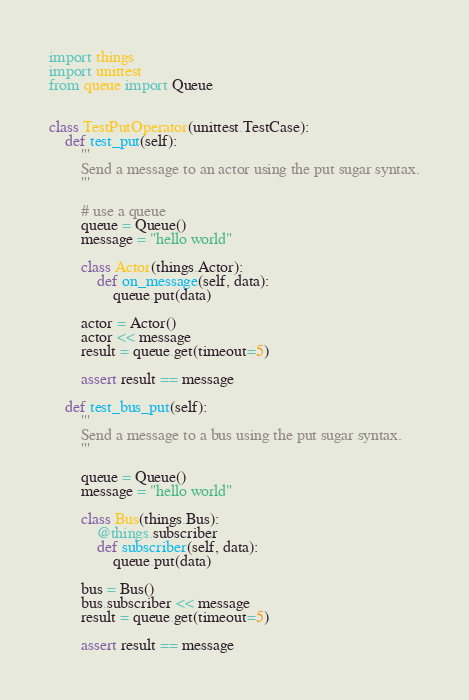<code> <loc_0><loc_0><loc_500><loc_500><_Python_>import things
import unittest
from queue import Queue


class TestPutOperator(unittest.TestCase):
    def test_put(self):
        '''
        Send a message to an actor using the put sugar syntax.
        '''

        # use a queue
        queue = Queue()
        message = "hello world"

        class Actor(things.Actor):
            def on_message(self, data):
                queue.put(data)

        actor = Actor()
        actor << message
        result = queue.get(timeout=5)

        assert result == message

    def test_bus_put(self):
        '''
        Send a message to a bus using the put sugar syntax.
        '''

        queue = Queue()
        message = "hello world"

        class Bus(things.Bus):
            @things.subscriber
            def subscriber(self, data):
                queue.put(data)

        bus = Bus()
        bus.subscriber << message
        result = queue.get(timeout=5)

        assert result == message
</code> 